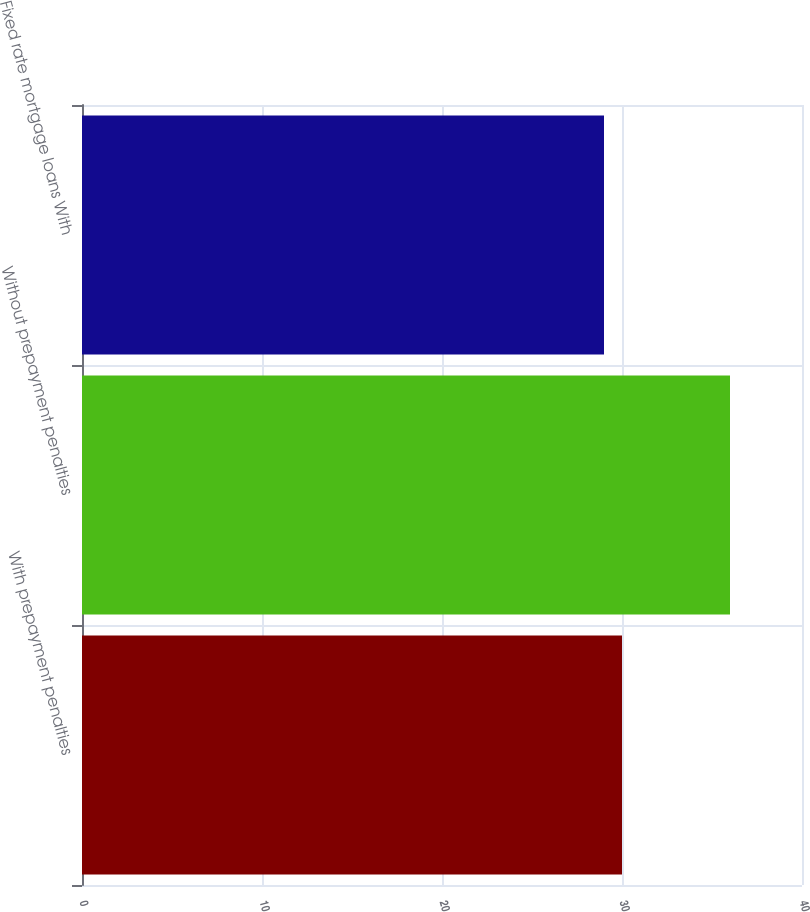Convert chart. <chart><loc_0><loc_0><loc_500><loc_500><bar_chart><fcel>With prepayment penalties<fcel>Without prepayment penalties<fcel>Fixed rate mortgage loans With<nl><fcel>30<fcel>36<fcel>29<nl></chart> 